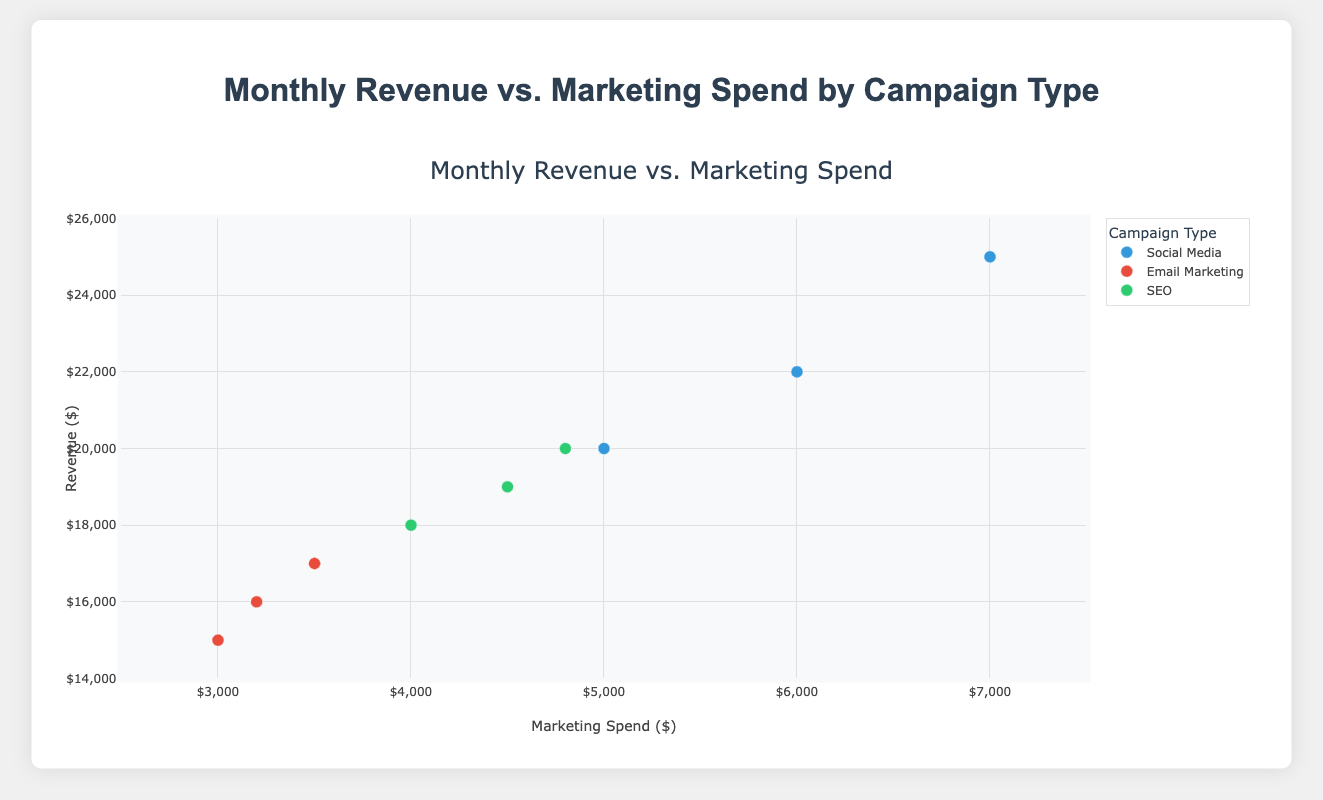What is the title of the plot? The title is typically located at the top center of the plot. It provides a summary of what the plot represents.
Answer: Monthly Revenue vs. Marketing Spend by Campaign Type How many campaign types are represented in the plot? There are different colors representing distinct campaign types in the plot's legend. By counting the distinct colors, we determine the number of campaign types.
Answer: 3 Which campaign type has the highest revenue? Look at the y-axis (Revenue) and identify the highest point. Check the corresponding campaign type of the highest point.
Answer: Social Media Which month has the highest marketing spend for TechSolutions Inc.? Filter the points by TechSolutions Inc. and look at the x-axis values to find the maximum. Identify the associated month.
Answer: March What is the range of the marketing spend in the dataset? The x-axis indicates the marketing spend. The range can be observed from the minimum to the maximum value on this axis.
Answer: 3000 to 7000 Which company has a marketing spend of 4500 in February? Locate the marketing spend of 4500 on the x-axis and filter by February. Identify the company associated with this point.
Answer: GreenEnergy Ltd Compare the revenue of HealthPlus Corp. in January and February. Which month was higher? Identify the revenue for HealthPlus Corp. in both months by looking at the y-axis values. Compare the two values to determine which is higher.
Answer: February What is the average revenue generated by SEO campaigns? Identify all points representing SEO campaigns. Sum their revenue values and divide by the number of such campaigns.
Answer: 19000 Are the majority of Email Marketing campaigns generating revenue above 15000? Identify points representing Email Marketing campaigns. Count how many have y-axis values above 15000 and compare with the total number of Email Marketing campaigns.
Answer: No Does marketing spend generally correlate with revenue? Look at the overall trend of the scatter plot. If points generally go upward from left to right, it suggests a positive correlation.
Answer: Yes 